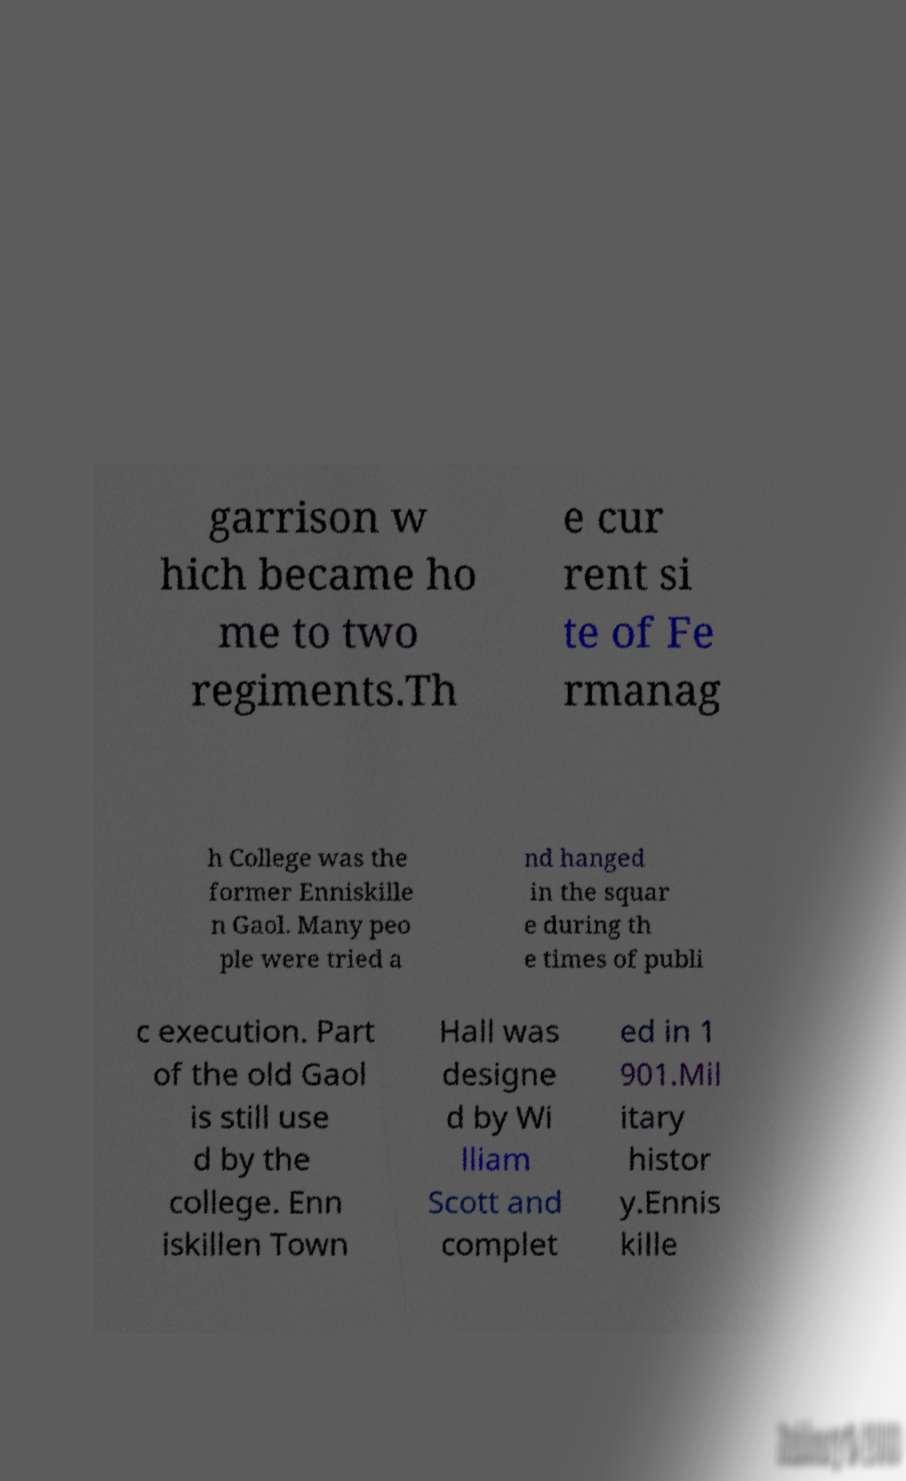What messages or text are displayed in this image? I need them in a readable, typed format. garrison w hich became ho me to two regiments.Th e cur rent si te of Fe rmanag h College was the former Enniskille n Gaol. Many peo ple were tried a nd hanged in the squar e during th e times of publi c execution. Part of the old Gaol is still use d by the college. Enn iskillen Town Hall was designe d by Wi lliam Scott and complet ed in 1 901.Mil itary histor y.Ennis kille 